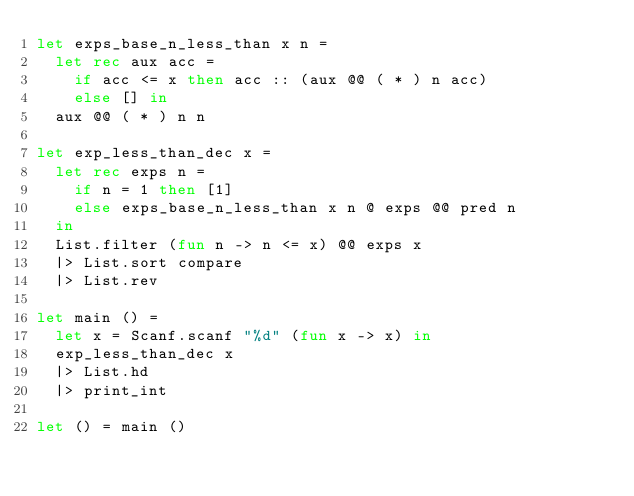Convert code to text. <code><loc_0><loc_0><loc_500><loc_500><_OCaml_>let exps_base_n_less_than x n =
  let rec aux acc =
    if acc <= x then acc :: (aux @@ ( * ) n acc)
    else [] in
  aux @@ ( * ) n n

let exp_less_than_dec x =
  let rec exps n =
    if n = 1 then [1]
    else exps_base_n_less_than x n @ exps @@ pred n
  in
  List.filter (fun n -> n <= x) @@ exps x
  |> List.sort compare
  |> List.rev

let main () =
  let x = Scanf.scanf "%d" (fun x -> x) in
  exp_less_than_dec x
  |> List.hd
  |> print_int

let () = main ()
</code> 